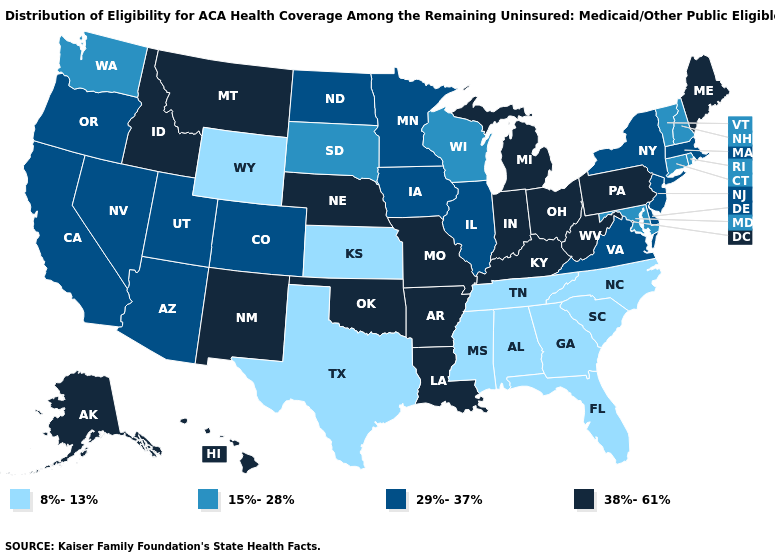Does the first symbol in the legend represent the smallest category?
Answer briefly. Yes. What is the value of Michigan?
Concise answer only. 38%-61%. Name the states that have a value in the range 29%-37%?
Quick response, please. Arizona, California, Colorado, Delaware, Illinois, Iowa, Massachusetts, Minnesota, Nevada, New Jersey, New York, North Dakota, Oregon, Utah, Virginia. Does the map have missing data?
Quick response, please. No. Does Kansas have the same value as Florida?
Give a very brief answer. Yes. Does Michigan have a lower value than Alabama?
Give a very brief answer. No. Name the states that have a value in the range 38%-61%?
Short answer required. Alaska, Arkansas, Hawaii, Idaho, Indiana, Kentucky, Louisiana, Maine, Michigan, Missouri, Montana, Nebraska, New Mexico, Ohio, Oklahoma, Pennsylvania, West Virginia. Does Florida have the same value as Idaho?
Keep it brief. No. Name the states that have a value in the range 29%-37%?
Keep it brief. Arizona, California, Colorado, Delaware, Illinois, Iowa, Massachusetts, Minnesota, Nevada, New Jersey, New York, North Dakota, Oregon, Utah, Virginia. Does Delaware have the lowest value in the South?
Quick response, please. No. What is the value of Oregon?
Quick response, please. 29%-37%. How many symbols are there in the legend?
Write a very short answer. 4. What is the value of Tennessee?
Write a very short answer. 8%-13%. Name the states that have a value in the range 29%-37%?
Write a very short answer. Arizona, California, Colorado, Delaware, Illinois, Iowa, Massachusetts, Minnesota, Nevada, New Jersey, New York, North Dakota, Oregon, Utah, Virginia. What is the highest value in states that border Virginia?
Write a very short answer. 38%-61%. 